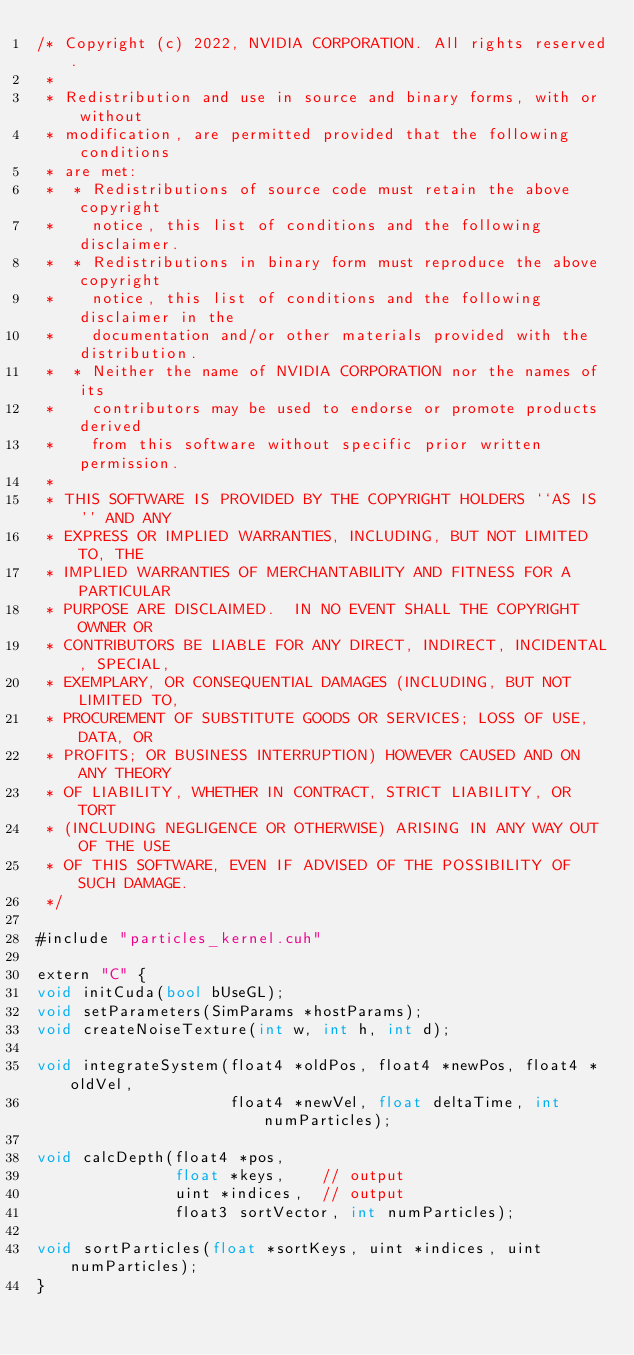<code> <loc_0><loc_0><loc_500><loc_500><_Cuda_>/* Copyright (c) 2022, NVIDIA CORPORATION. All rights reserved.
 *
 * Redistribution and use in source and binary forms, with or without
 * modification, are permitted provided that the following conditions
 * are met:
 *  * Redistributions of source code must retain the above copyright
 *    notice, this list of conditions and the following disclaimer.
 *  * Redistributions in binary form must reproduce the above copyright
 *    notice, this list of conditions and the following disclaimer in the
 *    documentation and/or other materials provided with the distribution.
 *  * Neither the name of NVIDIA CORPORATION nor the names of its
 *    contributors may be used to endorse or promote products derived
 *    from this software without specific prior written permission.
 *
 * THIS SOFTWARE IS PROVIDED BY THE COPYRIGHT HOLDERS ``AS IS'' AND ANY
 * EXPRESS OR IMPLIED WARRANTIES, INCLUDING, BUT NOT LIMITED TO, THE
 * IMPLIED WARRANTIES OF MERCHANTABILITY AND FITNESS FOR A PARTICULAR
 * PURPOSE ARE DISCLAIMED.  IN NO EVENT SHALL THE COPYRIGHT OWNER OR
 * CONTRIBUTORS BE LIABLE FOR ANY DIRECT, INDIRECT, INCIDENTAL, SPECIAL,
 * EXEMPLARY, OR CONSEQUENTIAL DAMAGES (INCLUDING, BUT NOT LIMITED TO,
 * PROCUREMENT OF SUBSTITUTE GOODS OR SERVICES; LOSS OF USE, DATA, OR
 * PROFITS; OR BUSINESS INTERRUPTION) HOWEVER CAUSED AND ON ANY THEORY
 * OF LIABILITY, WHETHER IN CONTRACT, STRICT LIABILITY, OR TORT
 * (INCLUDING NEGLIGENCE OR OTHERWISE) ARISING IN ANY WAY OUT OF THE USE
 * OF THIS SOFTWARE, EVEN IF ADVISED OF THE POSSIBILITY OF SUCH DAMAGE.
 */

#include "particles_kernel.cuh"

extern "C" {
void initCuda(bool bUseGL);
void setParameters(SimParams *hostParams);
void createNoiseTexture(int w, int h, int d);

void integrateSystem(float4 *oldPos, float4 *newPos, float4 *oldVel,
                     float4 *newVel, float deltaTime, int numParticles);

void calcDepth(float4 *pos,
               float *keys,    // output
               uint *indices,  // output
               float3 sortVector, int numParticles);

void sortParticles(float *sortKeys, uint *indices, uint numParticles);
}
</code> 